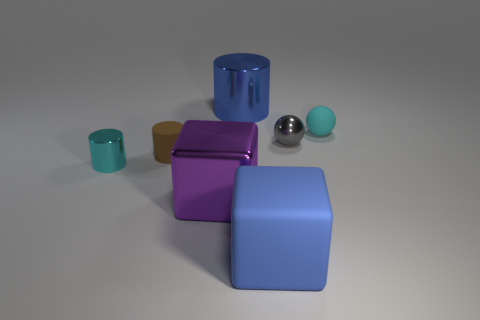Are there more cubes that are behind the large metal block than tiny cyan rubber spheres left of the small brown object?
Offer a terse response. No. There is a block on the right side of the large metal cylinder; what color is it?
Give a very brief answer. Blue. Do the metallic cylinder that is in front of the blue cylinder and the matte cylinder that is behind the blue rubber cube have the same size?
Offer a very short reply. Yes. What number of objects are either tiny gray spheres or small cyan metallic cylinders?
Your answer should be compact. 2. What material is the blue object in front of the shiny cylinder that is in front of the brown rubber cylinder?
Provide a short and direct response. Rubber. What number of small cyan matte things are the same shape as the tiny gray thing?
Offer a terse response. 1. Are there any other metallic cylinders of the same color as the big cylinder?
Make the answer very short. No. How many things are small cyan objects right of the blue matte cube or big blue things that are in front of the tiny cyan rubber thing?
Make the answer very short. 2. There is a small metallic thing behind the brown matte cylinder; are there any gray things right of it?
Offer a very short reply. No. There is a shiny object that is the same size as the blue cylinder; what is its shape?
Keep it short and to the point. Cube. 